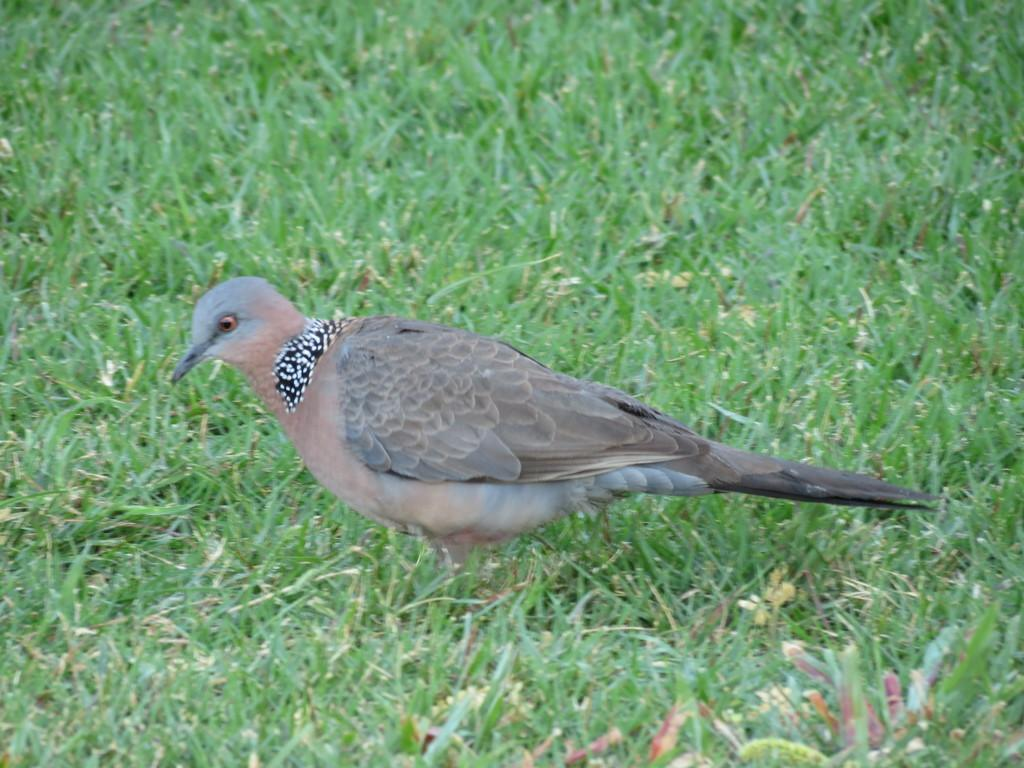What type of animal can be seen in the image? There is a bird in the image. Where is the bird located? The bird is on a grassy land. How many friends does the bird have in the image? There is no information about friends in the image, as it only features a bird on a grassy land. What type of bat can be seen in the image? There is no bat present in the image; it only features a bird on a grassy land. 